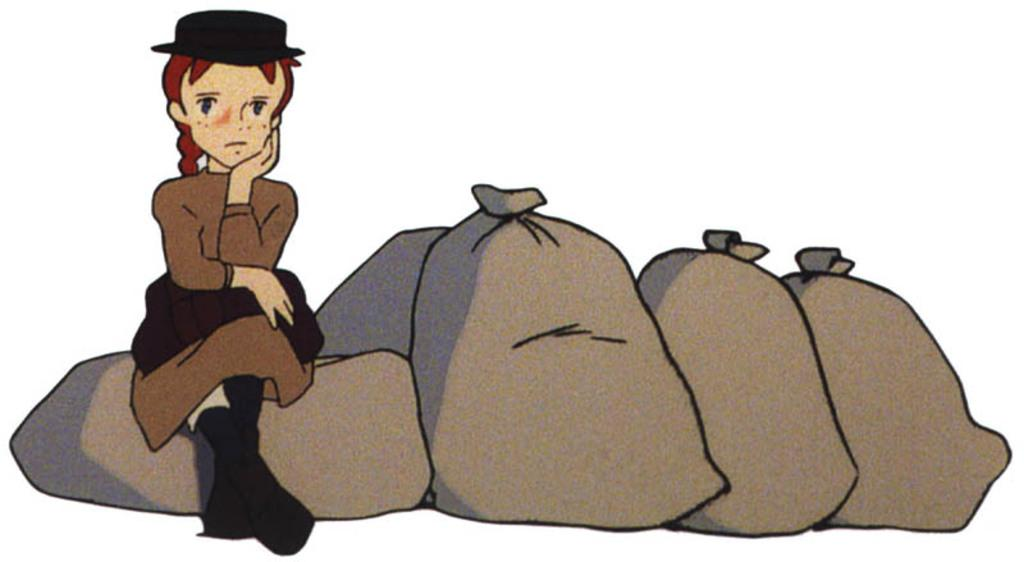What type of image is being described? The image is animated. What objects are present in the image? There are many gunny bags in the image. Who is present in the image? There is a girl in the image. What is the girl wearing? The girl is wearing a cap. What is the girl doing in the image? The girl is sitting on a gunny bag. What is the title of the animated movie that the image is from? The provided facts do not mention the title of an animated movie, so it cannot be determined from the image. Is the girl in the image sleeping? No, the girl is sitting on a gunny bag, not sleeping. 